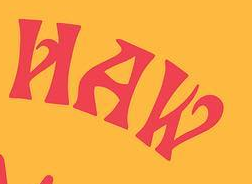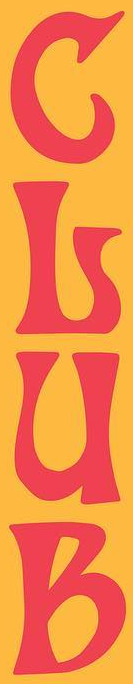Read the text content from these images in order, separated by a semicolon. HAW; GLUB 